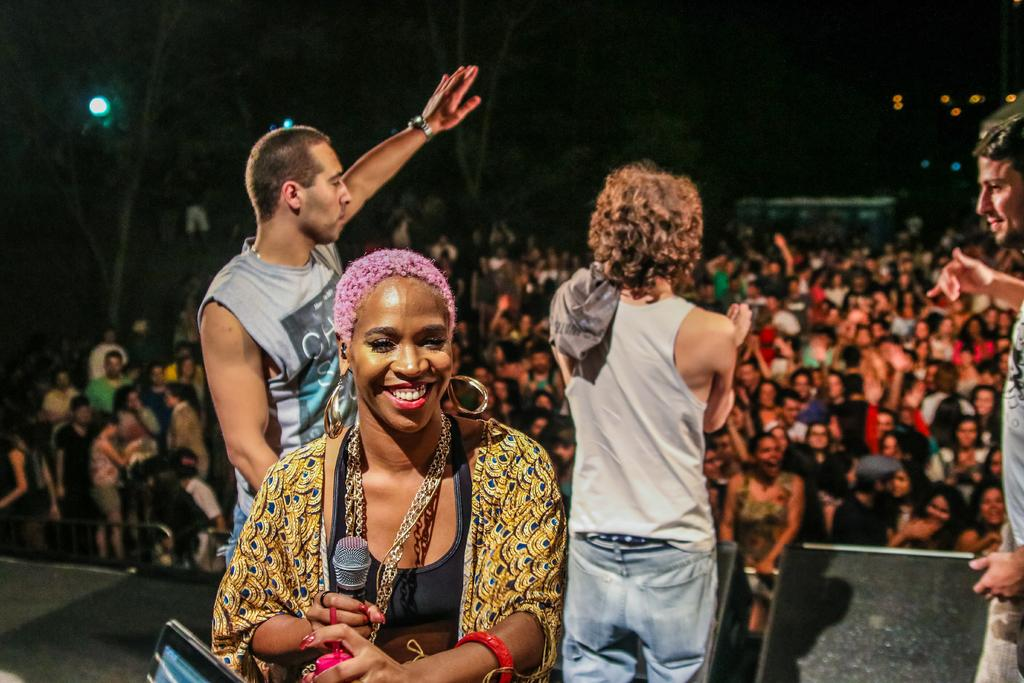What is happening in the image? There are people standing in the image, with four people on a dais. What is the person on the dais holding? One person on the dais is holding a microphone. What type of toothpaste is being advertised by the people on the dais? There is no toothpaste or advertisement present in the image; it simply shows people standing on a dais. 